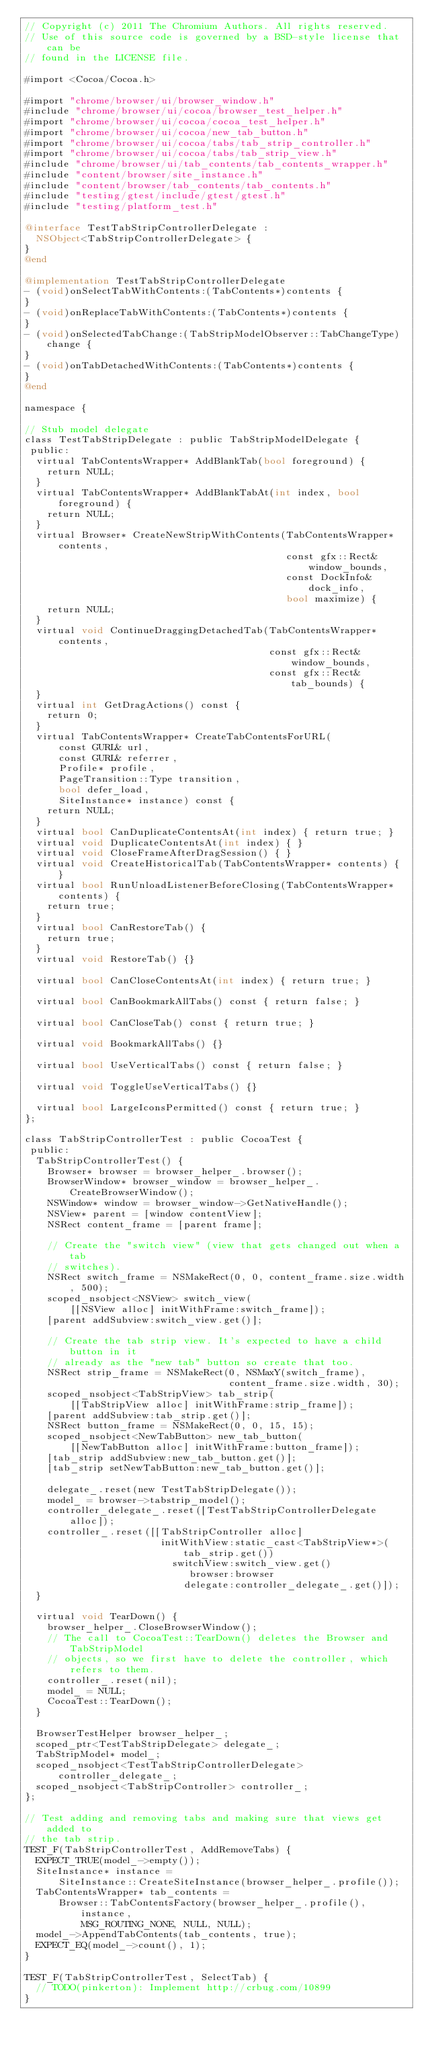Convert code to text. <code><loc_0><loc_0><loc_500><loc_500><_ObjectiveC_>// Copyright (c) 2011 The Chromium Authors. All rights reserved.
// Use of this source code is governed by a BSD-style license that can be
// found in the LICENSE file.

#import <Cocoa/Cocoa.h>

#import "chrome/browser/ui/browser_window.h"
#include "chrome/browser/ui/cocoa/browser_test_helper.h"
#import "chrome/browser/ui/cocoa/cocoa_test_helper.h"
#import "chrome/browser/ui/cocoa/new_tab_button.h"
#import "chrome/browser/ui/cocoa/tabs/tab_strip_controller.h"
#import "chrome/browser/ui/cocoa/tabs/tab_strip_view.h"
#include "chrome/browser/ui/tab_contents/tab_contents_wrapper.h"
#include "content/browser/site_instance.h"
#include "content/browser/tab_contents/tab_contents.h"
#include "testing/gtest/include/gtest/gtest.h"
#include "testing/platform_test.h"

@interface TestTabStripControllerDelegate :
  NSObject<TabStripControllerDelegate> {
}
@end

@implementation TestTabStripControllerDelegate
- (void)onSelectTabWithContents:(TabContents*)contents {
}
- (void)onReplaceTabWithContents:(TabContents*)contents {
}
- (void)onSelectedTabChange:(TabStripModelObserver::TabChangeType)change {
}
- (void)onTabDetachedWithContents:(TabContents*)contents {
}
@end

namespace {

// Stub model delegate
class TestTabStripDelegate : public TabStripModelDelegate {
 public:
  virtual TabContentsWrapper* AddBlankTab(bool foreground) {
    return NULL;
  }
  virtual TabContentsWrapper* AddBlankTabAt(int index, bool foreground) {
    return NULL;
  }
  virtual Browser* CreateNewStripWithContents(TabContentsWrapper* contents,
                                              const gfx::Rect& window_bounds,
                                              const DockInfo& dock_info,
                                              bool maximize) {
    return NULL;
  }
  virtual void ContinueDraggingDetachedTab(TabContentsWrapper* contents,
                                           const gfx::Rect& window_bounds,
                                           const gfx::Rect& tab_bounds) {
  }
  virtual int GetDragActions() const {
    return 0;
  }
  virtual TabContentsWrapper* CreateTabContentsForURL(
      const GURL& url,
      const GURL& referrer,
      Profile* profile,
      PageTransition::Type transition,
      bool defer_load,
      SiteInstance* instance) const {
    return NULL;
  }
  virtual bool CanDuplicateContentsAt(int index) { return true; }
  virtual void DuplicateContentsAt(int index) { }
  virtual void CloseFrameAfterDragSession() { }
  virtual void CreateHistoricalTab(TabContentsWrapper* contents) { }
  virtual bool RunUnloadListenerBeforeClosing(TabContentsWrapper* contents) {
    return true;
  }
  virtual bool CanRestoreTab() {
    return true;
  }
  virtual void RestoreTab() {}

  virtual bool CanCloseContentsAt(int index) { return true; }

  virtual bool CanBookmarkAllTabs() const { return false; }

  virtual bool CanCloseTab() const { return true; }

  virtual void BookmarkAllTabs() {}

  virtual bool UseVerticalTabs() const { return false; }

  virtual void ToggleUseVerticalTabs() {}

  virtual bool LargeIconsPermitted() const { return true; }
};

class TabStripControllerTest : public CocoaTest {
 public:
  TabStripControllerTest() {
    Browser* browser = browser_helper_.browser();
    BrowserWindow* browser_window = browser_helper_.CreateBrowserWindow();
    NSWindow* window = browser_window->GetNativeHandle();
    NSView* parent = [window contentView];
    NSRect content_frame = [parent frame];

    // Create the "switch view" (view that gets changed out when a tab
    // switches).
    NSRect switch_frame = NSMakeRect(0, 0, content_frame.size.width, 500);
    scoped_nsobject<NSView> switch_view(
        [[NSView alloc] initWithFrame:switch_frame]);
    [parent addSubview:switch_view.get()];

    // Create the tab strip view. It's expected to have a child button in it
    // already as the "new tab" button so create that too.
    NSRect strip_frame = NSMakeRect(0, NSMaxY(switch_frame),
                                    content_frame.size.width, 30);
    scoped_nsobject<TabStripView> tab_strip(
        [[TabStripView alloc] initWithFrame:strip_frame]);
    [parent addSubview:tab_strip.get()];
    NSRect button_frame = NSMakeRect(0, 0, 15, 15);
    scoped_nsobject<NewTabButton> new_tab_button(
        [[NewTabButton alloc] initWithFrame:button_frame]);
    [tab_strip addSubview:new_tab_button.get()];
    [tab_strip setNewTabButton:new_tab_button.get()];

    delegate_.reset(new TestTabStripDelegate());
    model_ = browser->tabstrip_model();
    controller_delegate_.reset([TestTabStripControllerDelegate alloc]);
    controller_.reset([[TabStripController alloc]
                        initWithView:static_cast<TabStripView*>(tab_strip.get())
                          switchView:switch_view.get()
                             browser:browser
                            delegate:controller_delegate_.get()]);
  }

  virtual void TearDown() {
    browser_helper_.CloseBrowserWindow();
    // The call to CocoaTest::TearDown() deletes the Browser and TabStripModel
    // objects, so we first have to delete the controller, which refers to them.
    controller_.reset(nil);
    model_ = NULL;
    CocoaTest::TearDown();
  }

  BrowserTestHelper browser_helper_;
  scoped_ptr<TestTabStripDelegate> delegate_;
  TabStripModel* model_;
  scoped_nsobject<TestTabStripControllerDelegate> controller_delegate_;
  scoped_nsobject<TabStripController> controller_;
};

// Test adding and removing tabs and making sure that views get added to
// the tab strip.
TEST_F(TabStripControllerTest, AddRemoveTabs) {
  EXPECT_TRUE(model_->empty());
  SiteInstance* instance =
      SiteInstance::CreateSiteInstance(browser_helper_.profile());
  TabContentsWrapper* tab_contents =
      Browser::TabContentsFactory(browser_helper_.profile(), instance,
          MSG_ROUTING_NONE, NULL, NULL);
  model_->AppendTabContents(tab_contents, true);
  EXPECT_EQ(model_->count(), 1);
}

TEST_F(TabStripControllerTest, SelectTab) {
  // TODO(pinkerton): Implement http://crbug.com/10899
}
</code> 